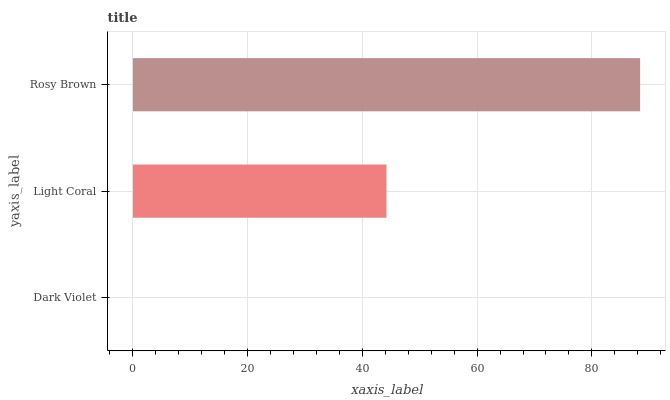Is Dark Violet the minimum?
Answer yes or no. Yes. Is Rosy Brown the maximum?
Answer yes or no. Yes. Is Light Coral the minimum?
Answer yes or no. No. Is Light Coral the maximum?
Answer yes or no. No. Is Light Coral greater than Dark Violet?
Answer yes or no. Yes. Is Dark Violet less than Light Coral?
Answer yes or no. Yes. Is Dark Violet greater than Light Coral?
Answer yes or no. No. Is Light Coral less than Dark Violet?
Answer yes or no. No. Is Light Coral the high median?
Answer yes or no. Yes. Is Light Coral the low median?
Answer yes or no. Yes. Is Dark Violet the high median?
Answer yes or no. No. Is Rosy Brown the low median?
Answer yes or no. No. 